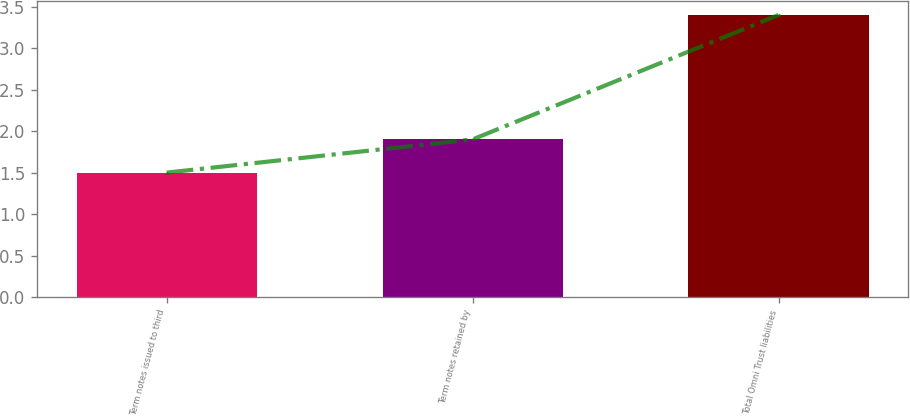Convert chart. <chart><loc_0><loc_0><loc_500><loc_500><bar_chart><fcel>Term notes issued to third<fcel>Term notes retained by<fcel>Total Omni Trust liabilities<nl><fcel>1.5<fcel>1.9<fcel>3.4<nl></chart> 